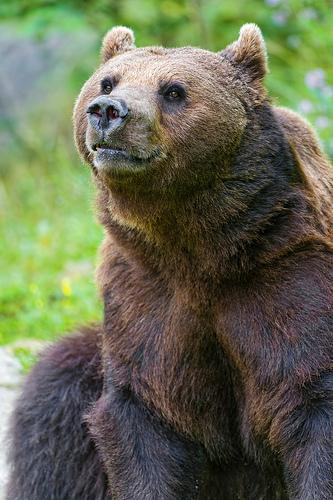Provide a brief description of the bear's head and facial features in a single sentence. A bear with a large black nose and brown eyes has brown ears and a very large brown head, surrounded by leaves in the background. In a few words, state what distinguishes this bear from a teddy bear. The bear in the image has more realistic features and a huge snout, unlike a teddy bear. Approximately how many leaves can be observed in the background? There are around four leaves in the background. What is the main subject of the image, and list three significant features of this subject? The main subject is a bear, and three significant features are brown eyes, large black nose, and brown ears. Describe the background elements found in the image. The background includes leaves, grass, vegetation, and unidentified objects, such as long reeds and a cement and/or gravel ground. Describe the bear's facial features in three words. Brown eyes, black nose, brown ears. Provide a detailed description of the bear's appearance. The bear has brown fur, brown eyes, large black nose, black mouth, a pair of brown ears, a brown head, neck, chest, and shoulders, and dark-colored back legs. Summarize the primary focus of the image in a single sentence. The image primarily features a close-up of a bear's face with distinct features such as brown eyes, black nose, and brown ears, surrounded by leaves and grass. Are there any objects near the bear that seems out of place or unusual? An unidentified object with bluish-gray color is present in the image. What color are the bear's eyes and nose in this image? The bear's eyes are brown, and the nose is black. 